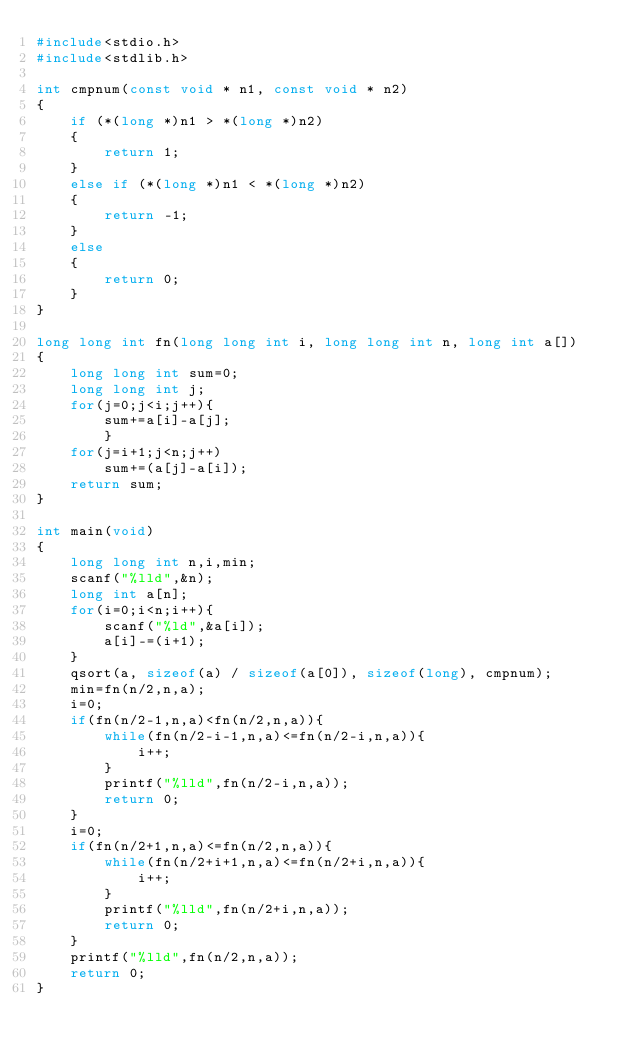<code> <loc_0><loc_0><loc_500><loc_500><_C_>#include<stdio.h>
#include<stdlib.h>

int cmpnum(const void * n1, const void * n2)
{
	if (*(long *)n1 > *(long *)n2)
	{
		return 1;
	}
	else if (*(long *)n1 < *(long *)n2)
	{
		return -1;
	}
	else
	{
		return 0;
	}
}

long long int fn(long long int i, long long int n, long int a[])
{
	long long int sum=0;
	long long int j;
	for(j=0;j<i;j++){
		sum+=a[i]-a[j];
		}
	for(j=i+1;j<n;j++)
		sum+=(a[j]-a[i]);
	return sum;
}

int main(void)
{
	long long int n,i,min;
	scanf("%lld",&n);
	long int a[n];
	for(i=0;i<n;i++){
		scanf("%ld",&a[i]);
		a[i]-=(i+1);
	}
	qsort(a, sizeof(a) / sizeof(a[0]), sizeof(long), cmpnum);
	min=fn(n/2,n,a);
	i=0;
	if(fn(n/2-1,n,a)<fn(n/2,n,a)){
		while(fn(n/2-i-1,n,a)<=fn(n/2-i,n,a)){
			i++;
		}
		printf("%lld",fn(n/2-i,n,a));
		return 0;
	}
	i=0;
	if(fn(n/2+1,n,a)<=fn(n/2,n,a)){
		while(fn(n/2+i+1,n,a)<=fn(n/2+i,n,a)){
			i++;
		}
		printf("%lld",fn(n/2+i,n,a));
		return 0;
	}
	printf("%lld",fn(n/2,n,a));	
	return 0;
}</code> 